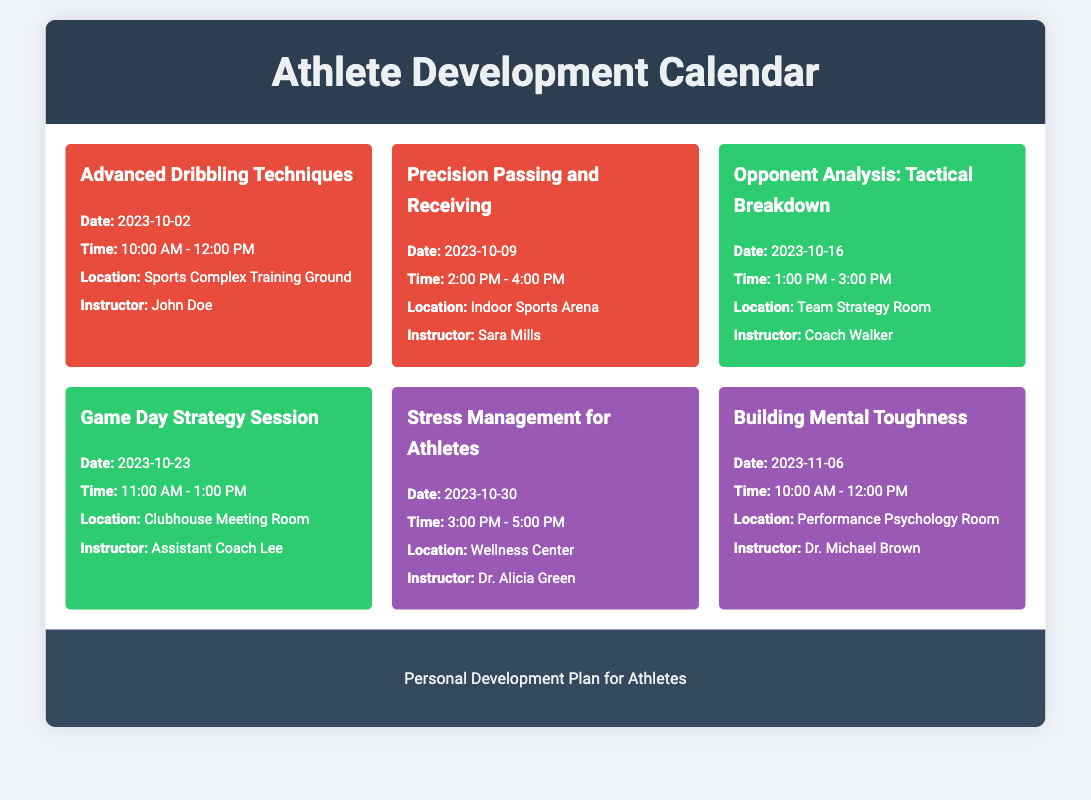What is the date for the Advanced Dribbling Techniques workshop? The date for the Advanced Dribbling Techniques workshop is listed in the document.
Answer: 2023-10-02 Who is the instructor for the Precision Passing and Receiving workshop? The instructor's name for this workshop is provided in the document.
Answer: Sara Mills What time does the Opponent Analysis: Tactical Breakdown session start? The start time for this tactical analysis session is indicated in the document.
Answer: 1:00 PM How many mental health sessions are listed in the calendar? The number of mental health sessions can be counted from the events mentioned in the document.
Answer: 2 What is the location for the Stress Management for Athletes session? The location for this session is specified in the document.
Answer: Wellness Center Which workshop focuses on building mental toughness? The title of the workshop dedicated to this topic is stated in the document.
Answer: Building Mental Toughness What is the theme color for Tactical Analysis meetings? The color associated with Tactical Analysis events is noted in the document.
Answer: Green Name the instructor for the Game Day Strategy Session. The instructor's name for this meeting is mentioned in the calendar.
Answer: Assistant Coach Lee 